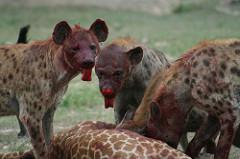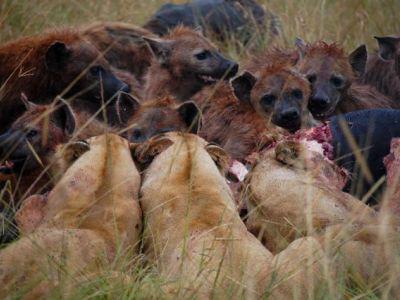The first image is the image on the left, the second image is the image on the right. For the images shown, is this caption "The left image contains one lion." true? Answer yes or no. No. The first image is the image on the left, the second image is the image on the right. Assess this claim about the two images: "In at least one image there is a lion eating a hyena by the neck.". Correct or not? Answer yes or no. No. 